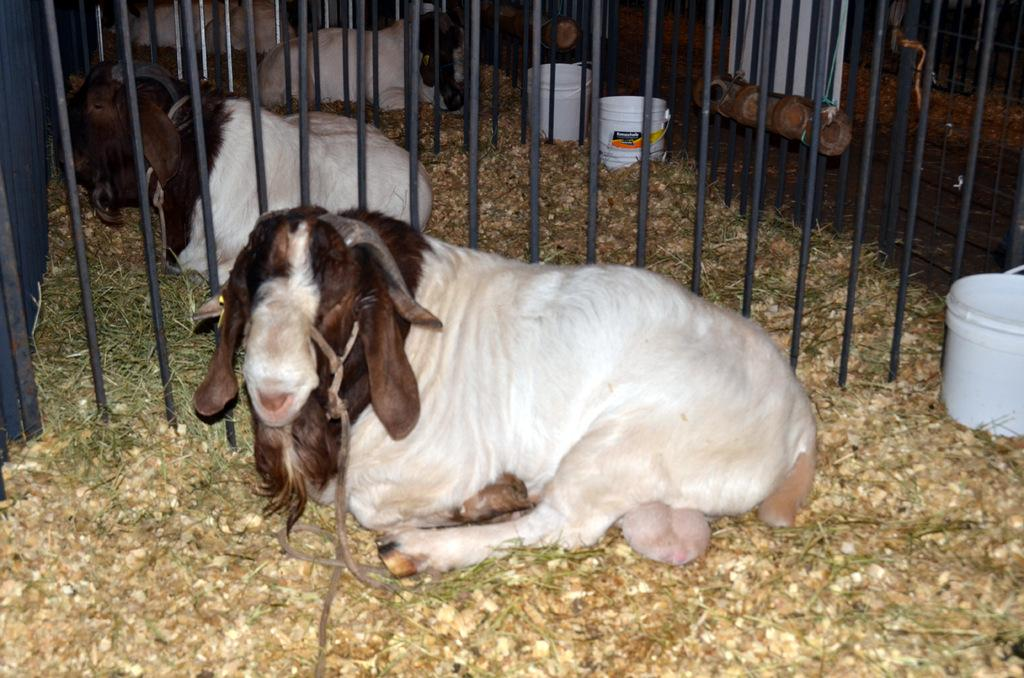What type of animals can be seen in the image? There are animals in the image, and they are in brown and white colors. What objects are present in the image alongside the animals? There are buckets and fencing visible in the image. What is the ground cover in the image? Dry grass is visible in the image. Where is the faucet located in the image? There is no faucet present in the image. How many cats can be seen interacting with the animals in the image? There are no cats present in the image. 